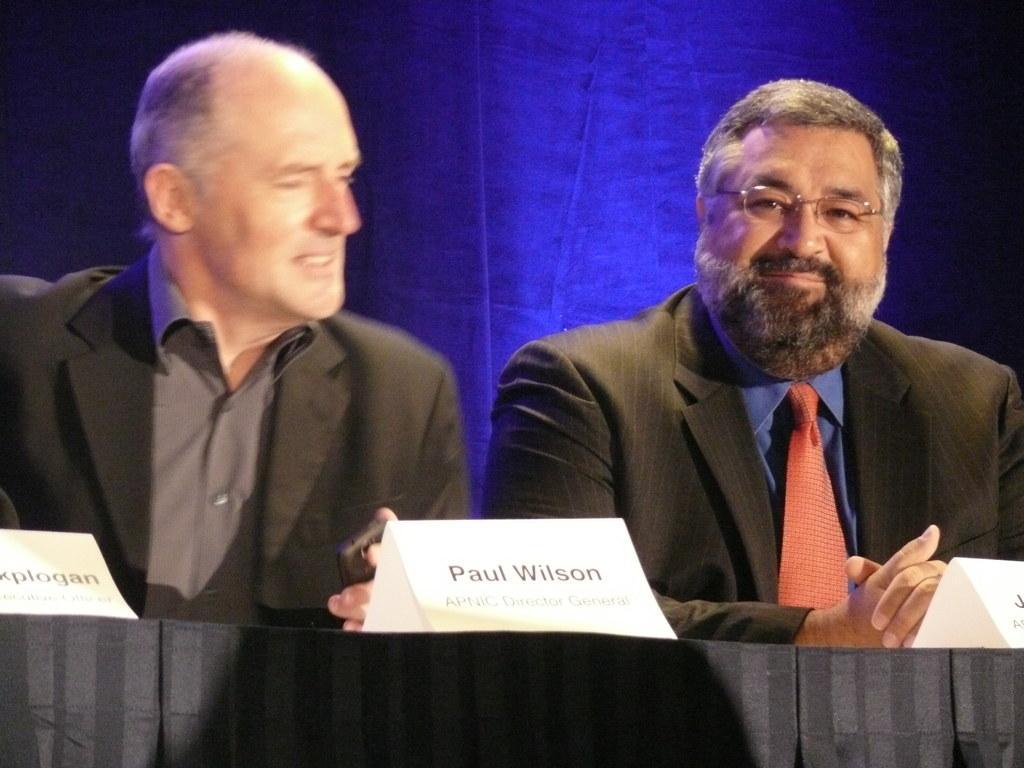Please provide a concise description of this image. In this picture we can see two men are sitting in front of a table, there is a cloth and three boards present on the table, we can see some text on these roads, a man on the right side wore spectacles. 